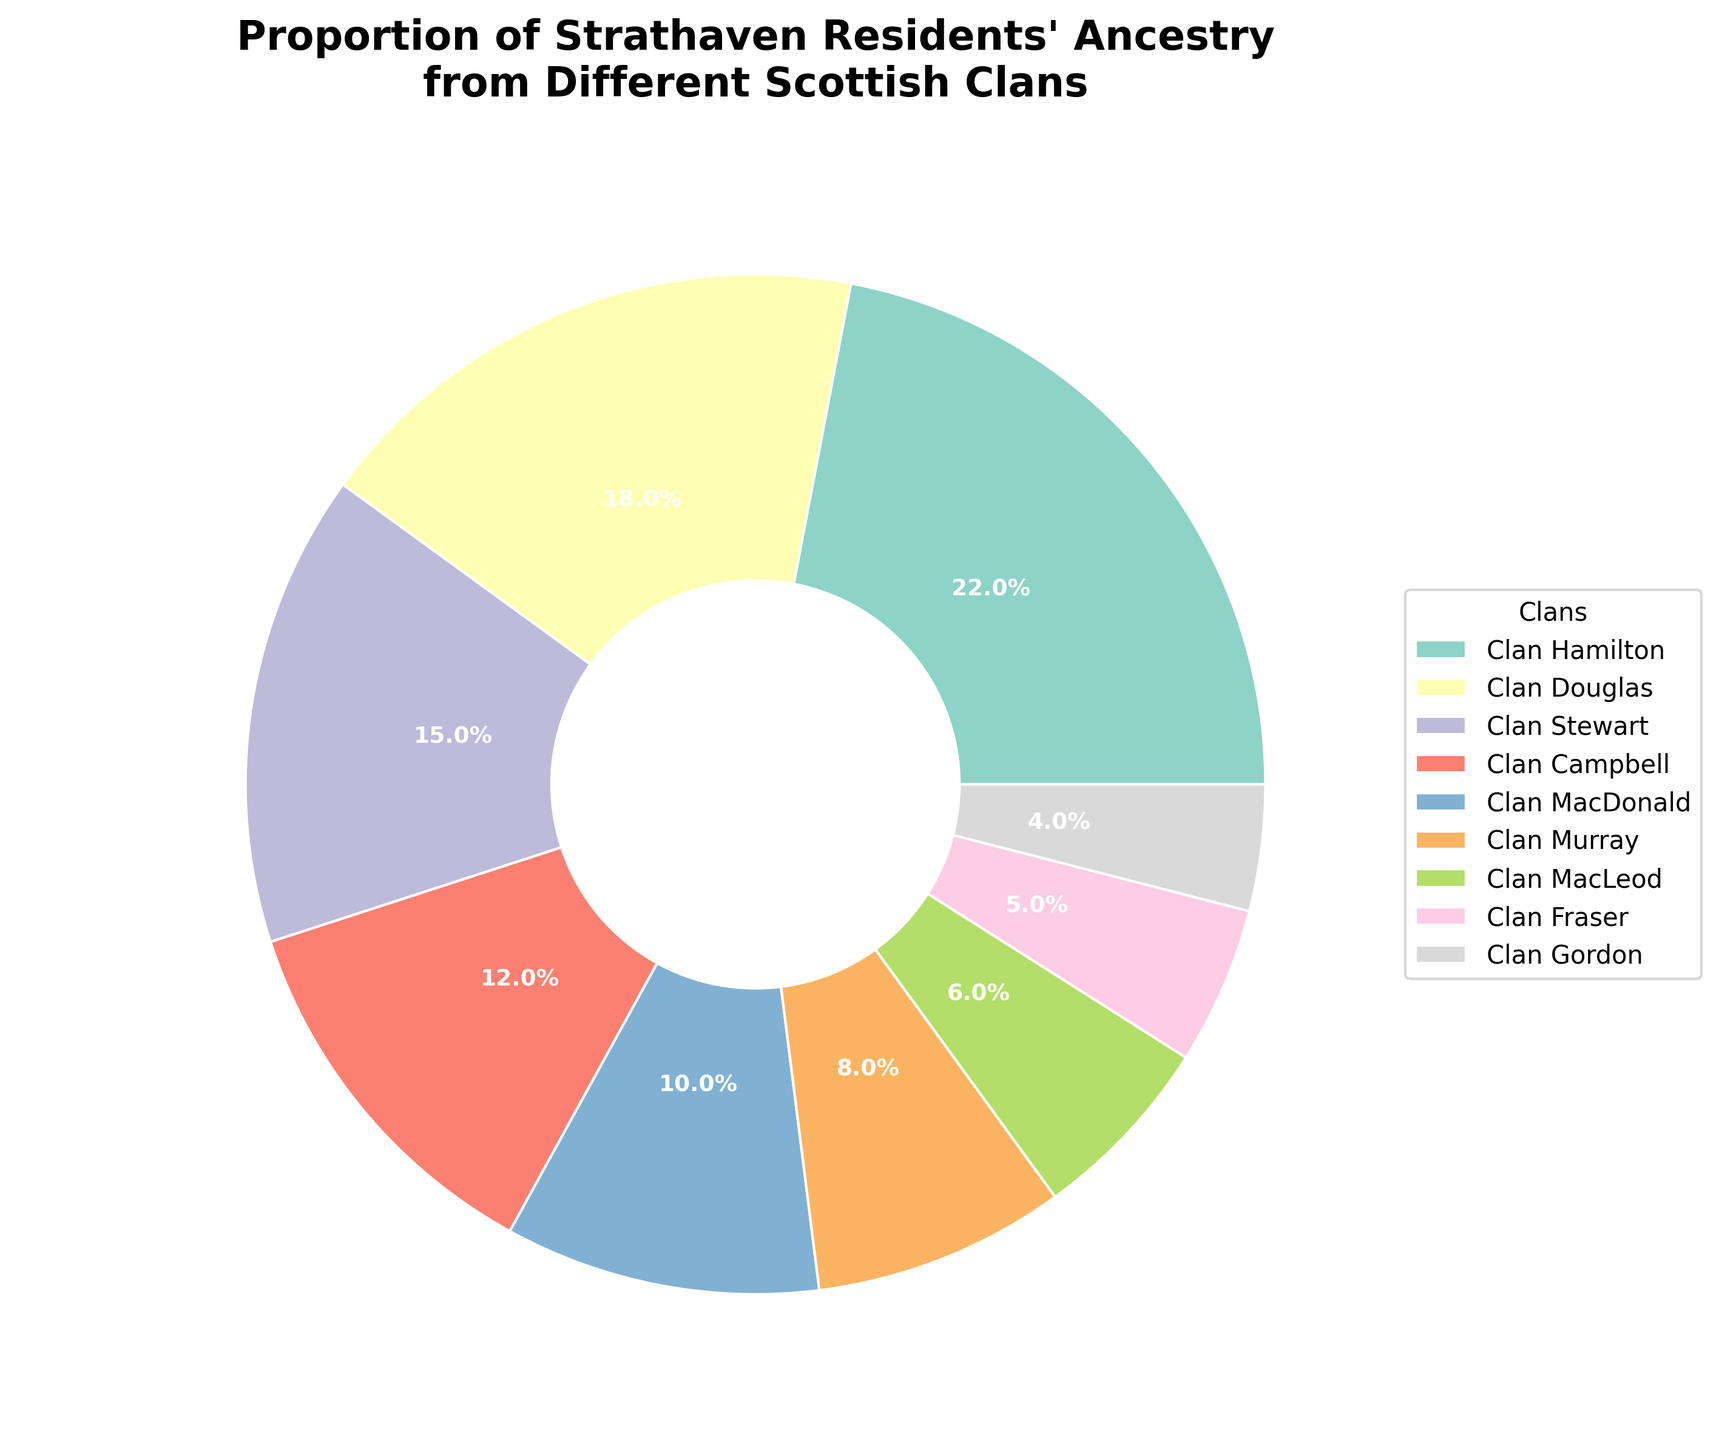What is the title of the pie chart? The title is at the top of the figure, helping to summarize the main topic of the pie chart. In this case, the title reads, "Proportion of Strathaven Residents' Ancestry from Different Scottish Clans."
Answer: Proportion of Strathaven Residents' Ancestry from Different Scottish Clans Which clan has the highest proportion of residents' ancestry according to the chart? To determine which clan has the highest proportion, look for the segment (wedge) with the largest percentage. The largest segment is labeled "Clan Hamilton" with 22%.
Answer: Clan Hamilton How many clans are represented in the pie chart? Count the number of distinct labels or segments in the pie chart. There are nine different segments, each labeled with a clan name.
Answer: 9 What is the combined percentage of residents’ ancestry from Clan Hamilton and Clan Douglas? The chart shows that Clan Hamilton has 22% and Clan Douglas has 18%. Adding these two values together: 22% + 18% = 40%.
Answer: 40% How does the proportion of Clan Stewart compare to Clan MacDonald? Clan Stewart's segment shows 15%, and Clan MacDonald's segment shows 10%. By comparing these values, we can see that Clan Stewart has a higher proportion than Clan MacDonald.
Answer: Clan Stewart has a higher proportion What is the difference in ancestry proportion between the clan with the highest proportion and the clan with the lowest proportion? Clan Hamilton has the highest proportion at 22%, and Clan Gordon has the lowest at 4%. The difference is calculated as 22% - 4% = 18%.
Answer: 18% Which three clans have the smallest proportions of residents' ancestry? Identify the three smallest segments in the pie chart based on their percentages. These are Clan Gordon (4%), Clan Fraser (5%), and Clan MacLeod (6%).
Answer: Clan Gordon, Clan Fraser, Clan MacLeod What is the average proportion of residents' ancestry for the clans presented in the chart? Add the percentages for all the clans and divide by the number of clans: (22% + 18% + 15% + 12% + 10% + 8% + 6% + 5% + 4%) / 9. The sum is 100%, and dividing by 9 equals approximately 11.1%.
Answer: 11.1% What's the total percentage of residents' ancestry from the four clans with the largest proportions? The four clans with the largest proportions are Clan Hamilton (22%), Clan Douglas (18%), Clan Stewart (15%), and Clan Campbell (12%). Summing these values: 22% + 18% + 15% + 12% = 67%.
Answer: 67% In terms of residents' ancestry, which clan has twice the proportion of Clan Fraser? Clan Fraser has 5%. To find the clan with twice this proportion: 5% * 2 = 10%. Clan MacDonald has exactly 10%.
Answer: Clan MacDonald 